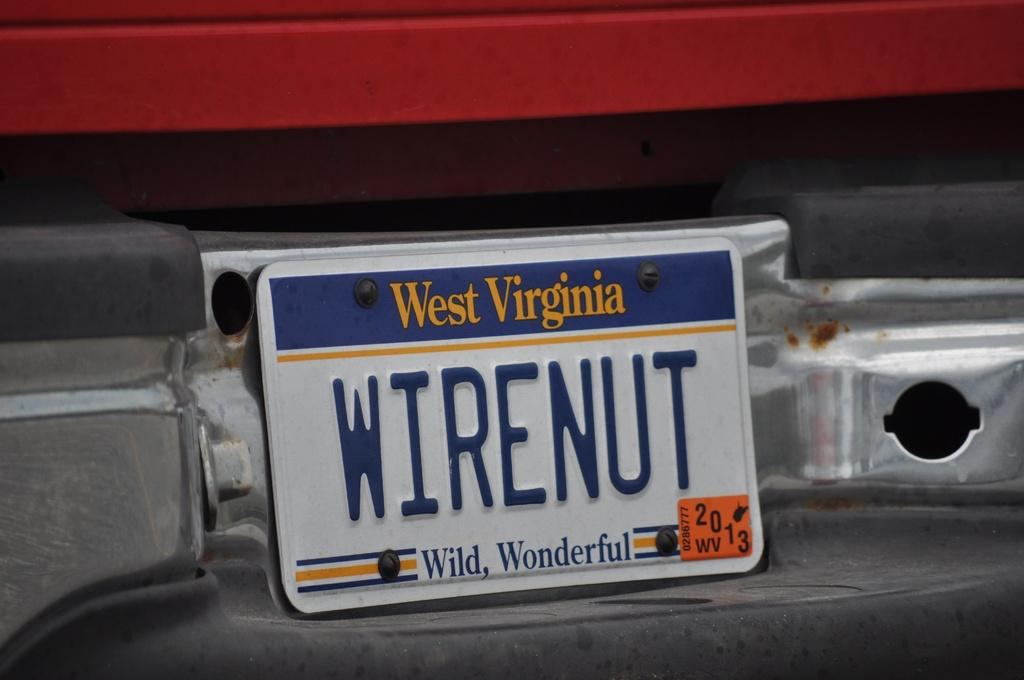What is the main subject of the picture? The main subject of the picture is a car. What is attached to the car? The car has a board on it. What is written on the board? The board has the name "West Virginia" and "wire nut, wild wonderful" written on it. What type of fear can be seen on the driver's face in the image? There is no driver or any indication of fear in the image; it only shows a car with a board on it. Can you tell me how many porters are assisting the passengers in the car? There are no passengers or porters present in the image; it only shows a car with a board on it. 